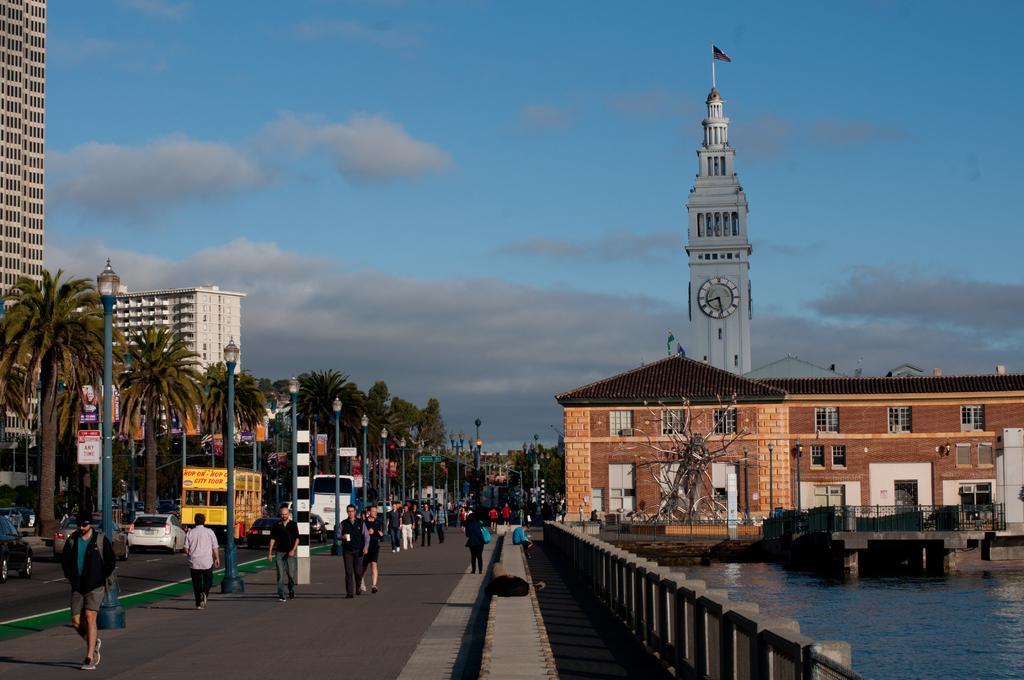Please provide a concise description of this image. In this image there are people walking on the road and there are vehicles passing on the other side of the road. Image also consists of many trees and also light poles. We can also see buildings and also clock tower. On the right there is lake and at the top there is sky with some clouds. 